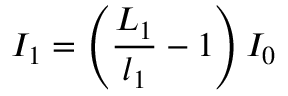<formula> <loc_0><loc_0><loc_500><loc_500>I _ { 1 } = \left ( \frac { L _ { 1 } } { l _ { 1 } } - 1 \right ) I _ { 0 }</formula> 